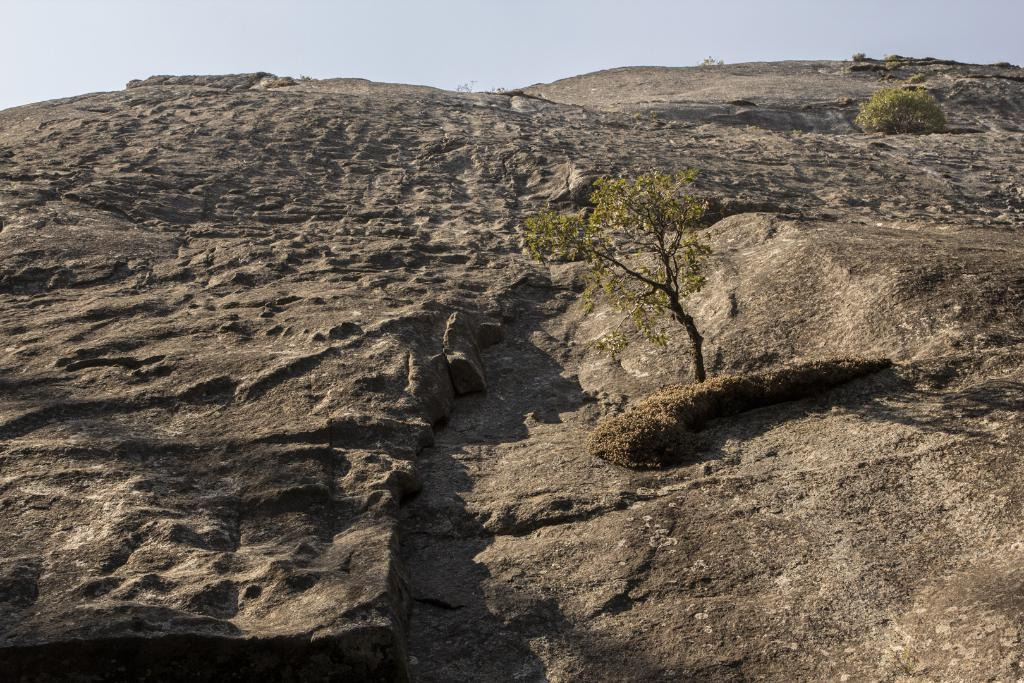What type of geographical feature is present in the image? There is a rock hill in the image. What can be seen on the rock hill? There is a tree on the hill. What other type of vegetation is present in the image? There is a plant on the right side of the image. What is visible in the background of the image? The sky is visible in the background of the image. How many bubbles can be seen floating around the tree in the image? There are no bubbles present in the image; it features a rock hill with a tree and a plant. Is there a visitor wearing a cap in the image? There is no visitor or cap present in the image. 